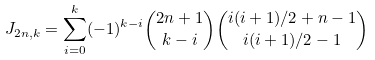Convert formula to latex. <formula><loc_0><loc_0><loc_500><loc_500>J _ { 2 n , k } = \sum _ { i = 0 } ^ { k } ( - 1 ) ^ { k - i } { 2 n + 1 \choose k - i } { i ( i + 1 ) / 2 + n - 1 \choose i ( i + 1 ) / 2 - 1 }</formula> 